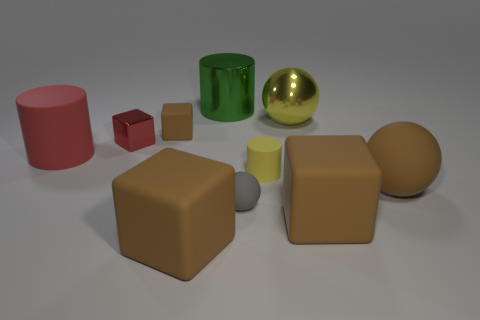There is a big cylinder that is behind the tiny brown cube; what material is it?
Your answer should be very brief. Metal. Does the large metallic object that is right of the green thing have the same color as the tiny cylinder?
Provide a short and direct response. Yes. There is a rubber object that is in front of the block right of the large yellow thing; what is its size?
Offer a terse response. Large. Is the number of small gray rubber objects that are behind the large metallic ball greater than the number of red rubber objects?
Make the answer very short. No. Does the cube that is to the right of the gray object have the same size as the green cylinder?
Keep it short and to the point. Yes. What is the color of the large rubber object that is both on the left side of the yellow metal object and in front of the tiny yellow matte thing?
Provide a short and direct response. Brown. What is the shape of the yellow rubber object that is the same size as the gray rubber sphere?
Keep it short and to the point. Cylinder. Is there another cube that has the same color as the tiny matte cube?
Provide a succinct answer. Yes. Are there the same number of tiny cubes right of the large brown matte ball and brown metal things?
Your answer should be compact. Yes. Do the metallic sphere and the small matte cylinder have the same color?
Offer a very short reply. Yes. 